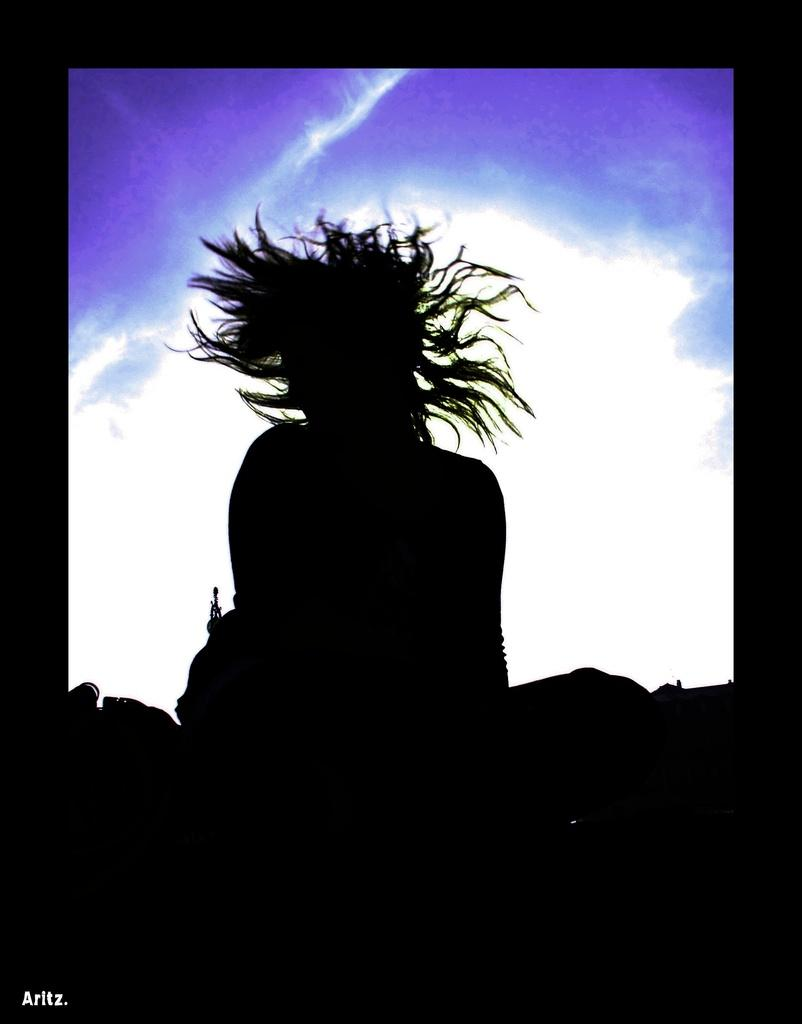Who or what is the main subject in the image? There is a person in the image. What can be seen in the background of the image? The background of the image is colorful. What type of order does the person in the image place? There is no indication in the image that the person is placing an order, so it cannot be determined from the picture. 